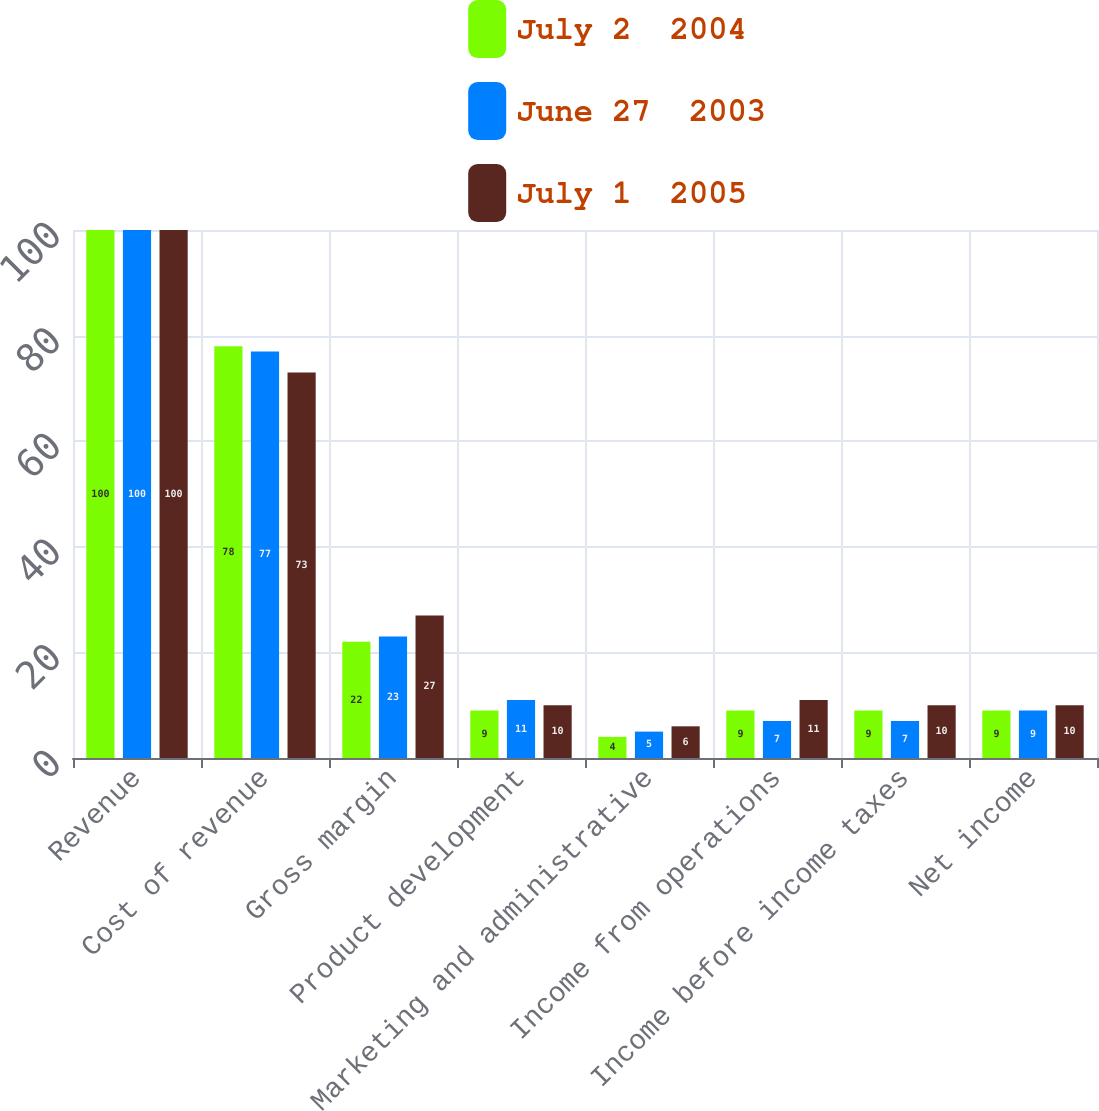<chart> <loc_0><loc_0><loc_500><loc_500><stacked_bar_chart><ecel><fcel>Revenue<fcel>Cost of revenue<fcel>Gross margin<fcel>Product development<fcel>Marketing and administrative<fcel>Income from operations<fcel>Income before income taxes<fcel>Net income<nl><fcel>July 2  2004<fcel>100<fcel>78<fcel>22<fcel>9<fcel>4<fcel>9<fcel>9<fcel>9<nl><fcel>June 27  2003<fcel>100<fcel>77<fcel>23<fcel>11<fcel>5<fcel>7<fcel>7<fcel>9<nl><fcel>July 1  2005<fcel>100<fcel>73<fcel>27<fcel>10<fcel>6<fcel>11<fcel>10<fcel>10<nl></chart> 